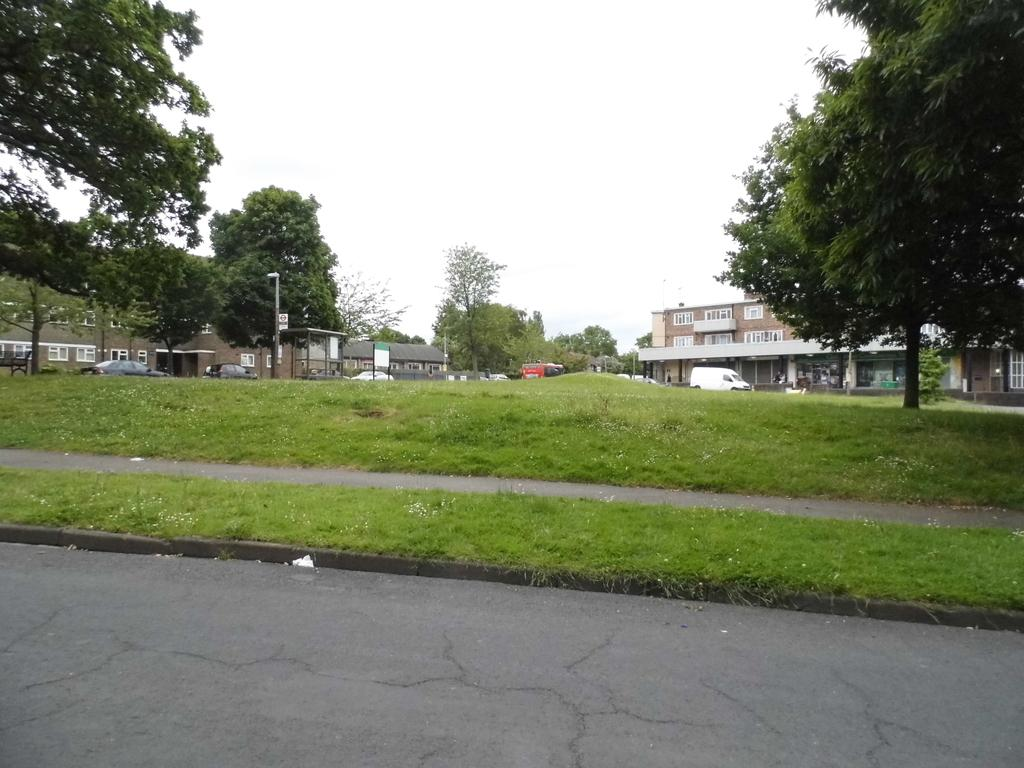What is the main object in the image? There is a rod in the image. What type of terrain is visible in the image? There is grass on the ground in the image. What type of man-made structures can be seen in the image? There are houses in the image. What type of vehicles are present in the image? There are cars in the image. What type of vegetation is present in the image? There are trees in the image. What is visible in the background of the image? The sky is visible in the background of the image. What type of sand can be seen in the image? There is no sand present in the image. What type of drum is being played in the image? There is no drum present in the image. 